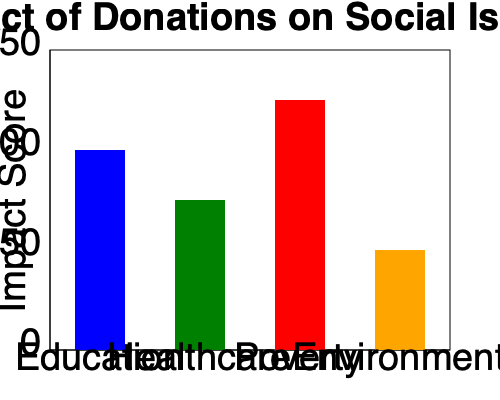As a visionary leader overseeing charitable fund distribution, you are presented with a bar graph showing the impact of donations on various social issues. Based on the graph, which social issue has received the most effective use of donations, resulting in the highest impact score? To determine which social issue has received the most effective use of donations, we need to analyze the bar graph and compare the impact scores for each social issue:

1. Identify the social issues represented:
   - Education (blue bar)
   - Healthcare (green bar)
   - Poverty (red bar)
   - Environment (orange bar)

2. Compare the heights of the bars:
   - Education: Approximately 100 impact score
   - Healthcare: Approximately 75 impact score
   - Poverty: Approximately 125 impact score
   - Environment: Approximately 50 impact score

3. Identify the highest bar:
   The red bar, representing poverty, has the highest impact score of approximately 125.

4. Interpret the result:
   The highest impact score indicates that donations towards poverty alleviation have been most effectively used, resulting in the greatest positive impact among the four social issues presented.
Answer: Poverty 